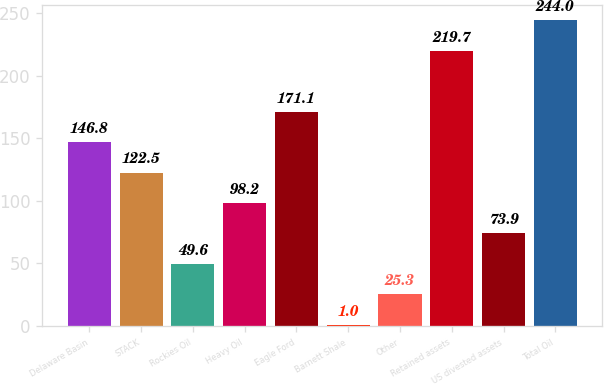Convert chart to OTSL. <chart><loc_0><loc_0><loc_500><loc_500><bar_chart><fcel>Delaware Basin<fcel>STACK<fcel>Rockies Oil<fcel>Heavy Oil<fcel>Eagle Ford<fcel>Barnett Shale<fcel>Other<fcel>Retained assets<fcel>US divested assets<fcel>Total Oil<nl><fcel>146.8<fcel>122.5<fcel>49.6<fcel>98.2<fcel>171.1<fcel>1<fcel>25.3<fcel>219.7<fcel>73.9<fcel>244<nl></chart> 